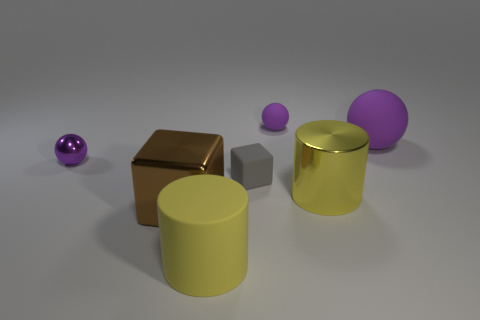Are there the same number of small rubber spheres that are to the left of the tiny metal ball and tiny purple rubber objects?
Keep it short and to the point. No. How many things are the same color as the big rubber ball?
Ensure brevity in your answer.  2. What is the color of the metal thing that is the same shape as the gray rubber thing?
Keep it short and to the point. Brown. Is the yellow matte object the same size as the shiny sphere?
Your answer should be compact. No. Is the number of purple objects that are in front of the metallic sphere the same as the number of large purple rubber things that are on the right side of the large metal cube?
Your response must be concise. No. Are there any metal balls?
Your answer should be compact. Yes. There is another thing that is the same shape as the yellow matte thing; what size is it?
Make the answer very short. Large. There is a purple object left of the big brown metal block; how big is it?
Make the answer very short. Small. Are there more large yellow metal things that are left of the shiny cube than rubber objects?
Make the answer very short. No. The small metal thing is what shape?
Keep it short and to the point. Sphere. 